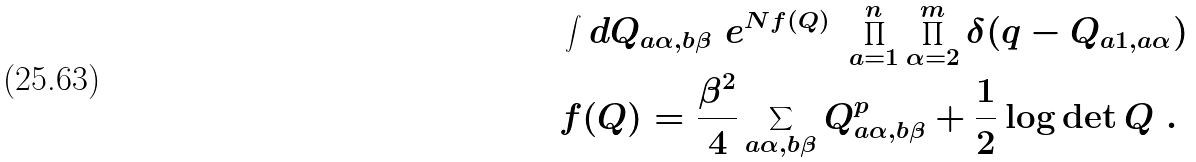<formula> <loc_0><loc_0><loc_500><loc_500>& \int d Q _ { a \alpha , b \beta } \ e ^ { N f ( Q ) } \ \prod _ { a = 1 } ^ { n } \prod _ { \alpha = 2 } ^ { m } \delta ( q - Q _ { a 1 , a \alpha } ) \\ & f ( Q ) = \frac { \beta ^ { 2 } } { 4 } \sum _ { a \alpha , b \beta } Q _ { a \alpha , b \beta } ^ { p } + \frac { 1 } { 2 } \log \det Q \ .</formula> 